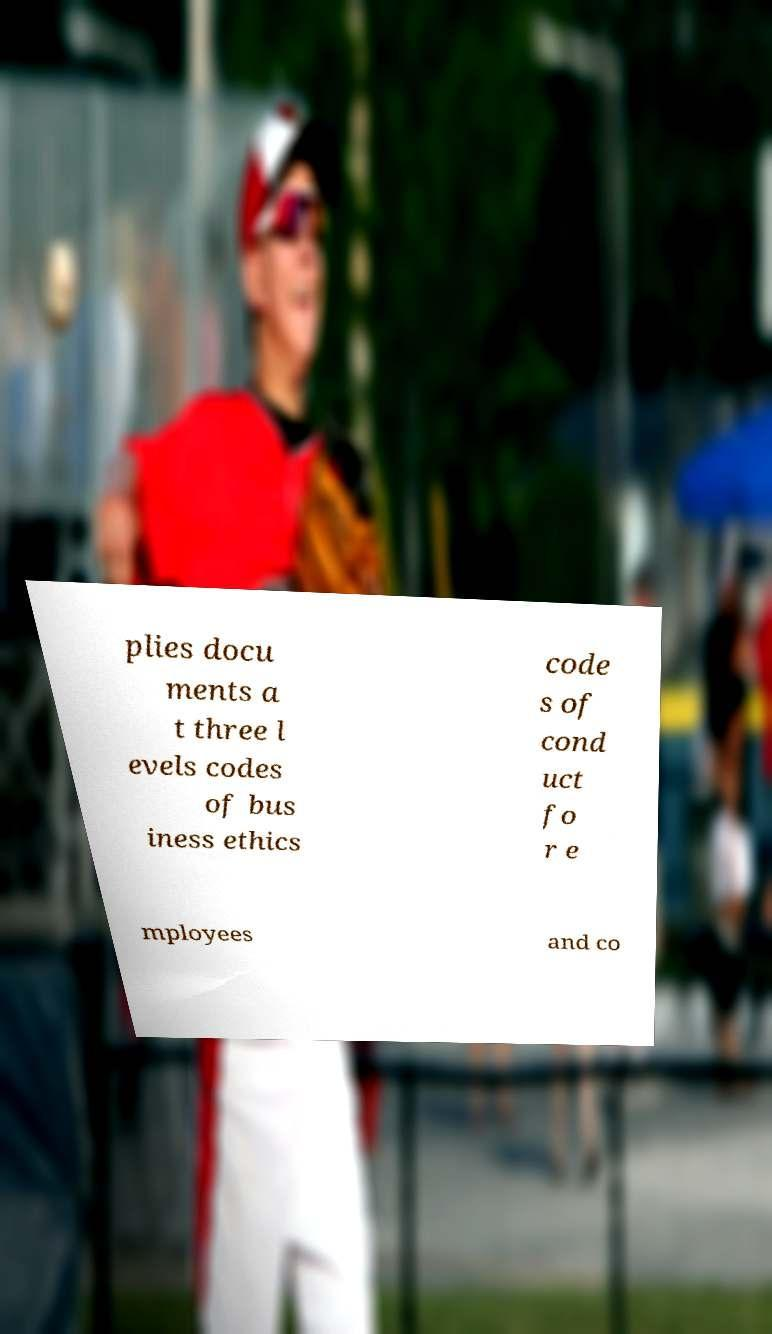Can you accurately transcribe the text from the provided image for me? plies docu ments a t three l evels codes of bus iness ethics code s of cond uct fo r e mployees and co 